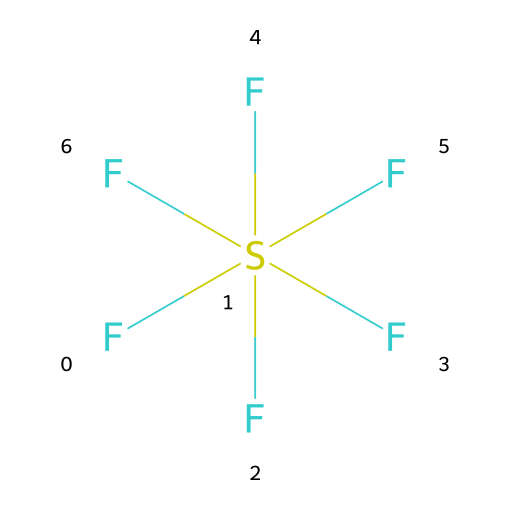how many fluorine atoms are present in sulfur hexafluoride? In the SMILES representation, F[S](F)(F)(F)(F)F shows the sulfur atom (S) is surrounded by six fluorine (F) atoms. Counting each "F" in the structure gives a total of six fluorine atoms.
Answer: six what is the total number of atoms in sulfur hexafluoride? The chemical consists of one sulfur atom (S) and six fluorine atoms (F). Adding them together gives a total of seven atoms in the molecule.
Answer: seven what geometry does sulfur hexafluoride exhibit? Sulfur hexafluoride has an octahedral geometry due to the arrangement of six fluorine atoms around the sulfur atom, maximizing their distance from each other in three-dimensional space.
Answer: octahedral is sulfur hexafluoride polar or nonpolar? Given that sulfur hexafluoride has symmetrical arrangement of the six fluorine atoms around the sulfur atom, the dipoles cancel out, making the molecule nonpolar overall.
Answer: nonpolar what is a common use of sulfur hexafluoride in the film industry? Sulfur hexafluoride is commonly used in the film industry to create deep voice effects, as it is denser than air and alters sound frequencies when inhaled.
Answer: deep voice effects what type of compound is sulfur hexafluoride classified as? Sulfur hexafluoride is classified as a sulfur compound, specifically as a fluorinated compound due to the presence of fluorine atoms.
Answer: fluorinated compound 